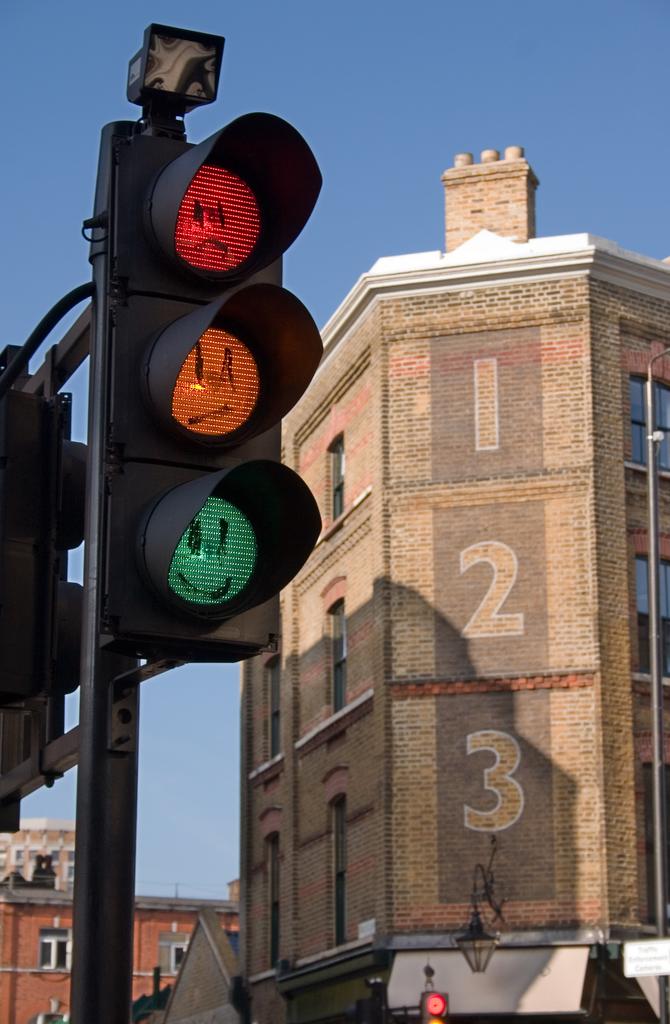What is the middle number on the building?
Ensure brevity in your answer.  2. What is the number on top?
Keep it short and to the point. 1. 